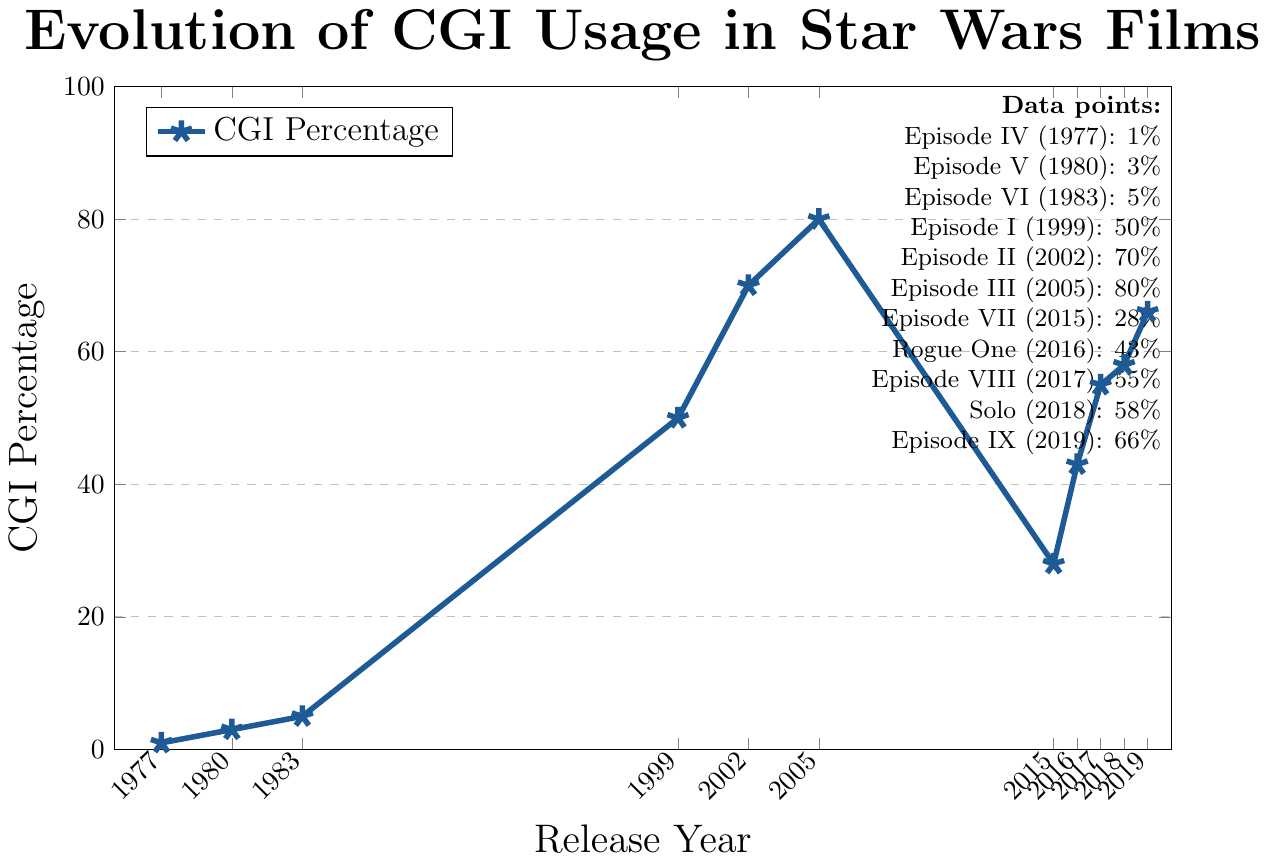What is the percentage of CGI shots in Episode I: The Phantom Menace (1999)? Look for the data point corresponding to Episode I in 1999 and read the CGI percentage.
Answer: 50% Which Star Wars film has the highest percentage of CGI shots? Identify the data point with the highest CGI percentage in the figure, which is Episode III: Revenge of the Sith (2005) with 80%.
Answer: Episode III: Revenge of the Sith (2005) How much did the usage of CGI increase from Episode VI: Return of the Jedi (1983) to Episode I: The Phantom Menace (1999)? Subtract the percentage of CGI in 1983 (5%) from the percentage in 1999 (50%).
Answer: 45% Between which two consecutive movies is the largest increase in CGI usage observed? Identify the pairs of consecutive movies and calculate the differences. The largest increase is between Episode VI (1983) and Episode I (1999), from 5% to 50%.
Answer: Episode VI (1983) to Episode I (1999) Which movie released between 2015 and 2019 had the lowest percentage of CGI shots? Identify the movies released between 2015 and 2019 and find the one with the lowest percentage. Episode VII: The Force Awakens (2015) had 28%.
Answer: Episode VII: The Force Awakens (2015) How did the CGI usage change from Episode VII: The Force Awakens (2015) to Episode IX: The Rise of Skywalker (2019)? Subtract the CGI percentage in 2015 (28%) from the percentage in 2019 (66%).
Answer: increased by 38% What is the average CGI percentage across all the movies listed in the figure? Sum the CGI percentages for all movies and divide by the number of movies (11). The sum is 459, so the average is 459/11 = 41.73.
Answer: 41.73% Which movie had a higher percentage of CGI shots: Episode VIII: The Last Jedi (2017) or Solo: A Star Wars Story (2018)? Compare the CGI percentages for the two movies: Episode VIII had 55%, and Solo had 58%.
Answer: Solo: A Star Wars Story (2018) What was the percentage change in CGI usage from Rogue One: A Star Wars Story (2016) to Episode IX: The Rise of Skywalker (2019)? Subtract the percentage in 2016 (43%) from the percentage in 2019 (66%) and then divide by the 2016 percentage (43%), finally multiply by 100 to get percentage change: (66-43)/43*100.
Answer: 53.49% How many times higher was the CGI usage in Episode III: Revenge of the Sith (2005) compared to Episode IV: A New Hope (1977)? Divide the percentage in 2005 (80%) by the percentage in 1977 (1%).
Answer: 80 times 